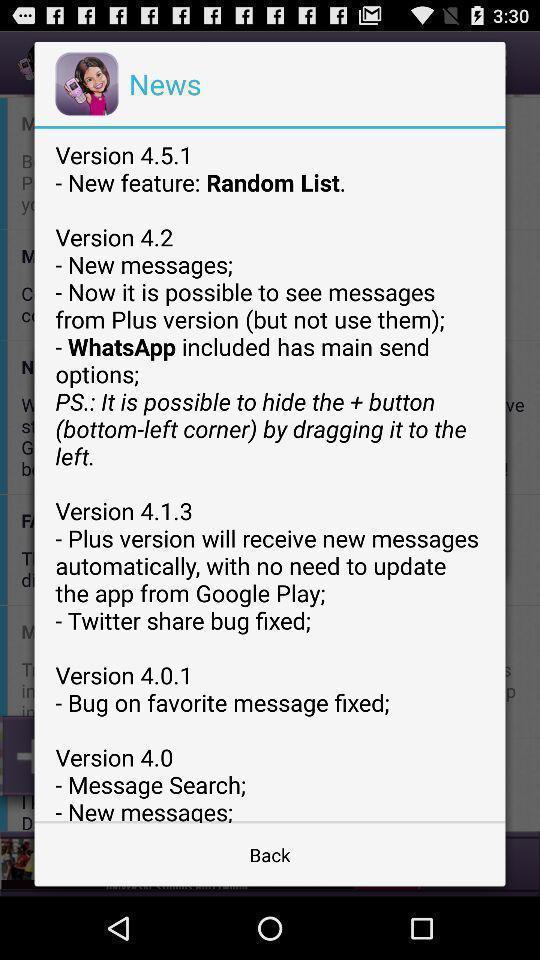Describe the visual elements of this screenshot. Pop-up shows version. 